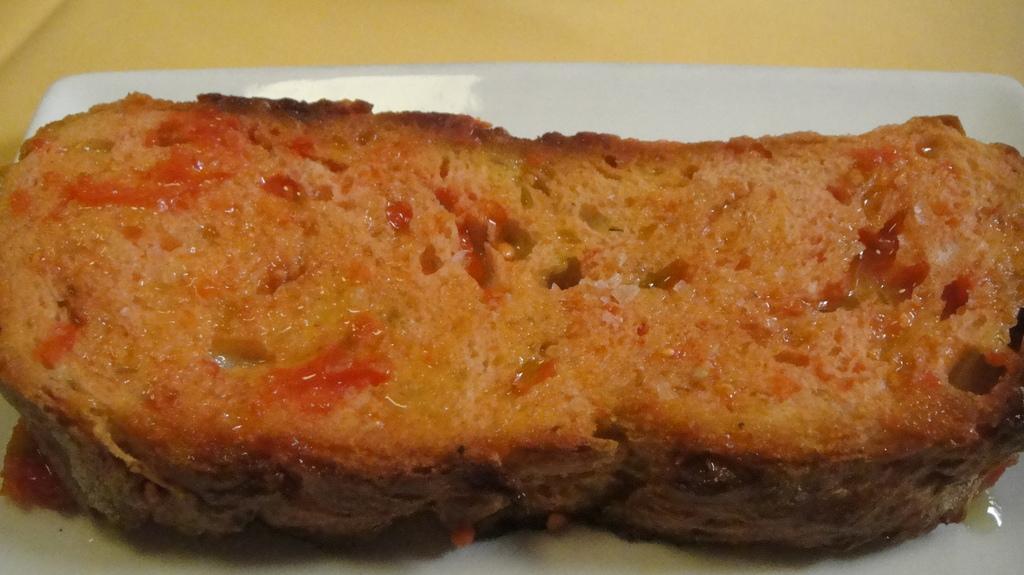Can you describe this image briefly? In this image I can see a food item on the plate which is placed on the surface. 